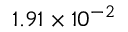<formula> <loc_0><loc_0><loc_500><loc_500>1 . 9 1 \times 1 0 ^ { - 2 }</formula> 